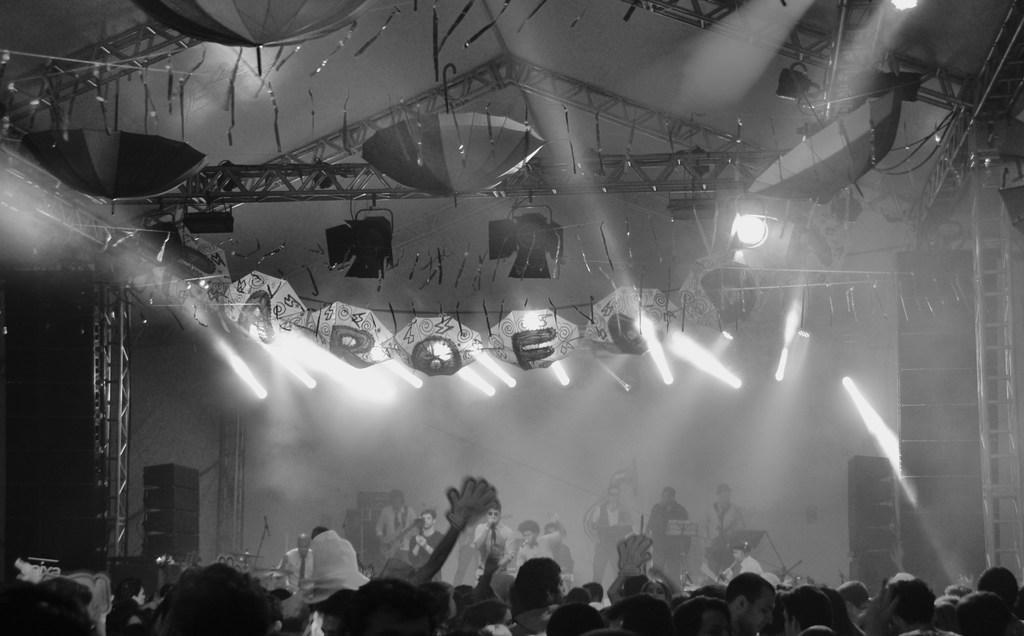Can you describe this image briefly? This is a black and white image. At the bottom of the image there are few people standing. Behind them there are few people playing musical instruments and also there are speakers. In the background there are rods. At the top of the image there is a ceiling. There are many umbrellas hanging and also there are lights. 